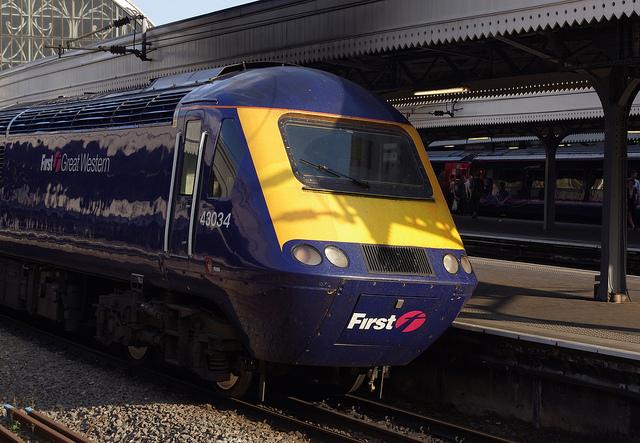Is the train located outdoors?
Write a very short answer. Yes. Why is everyone so far back in the train station?
Quick response, please. Safety. Are the headlights on?
Be succinct. No. What is the brand of train?
Short answer required. First. What number is on the left side of the train?
Write a very short answer. 43034. How many trains are there?
Be succinct. 1. What kind of train is this?
Answer briefly. Passenger. Does this train appear to be brand new?
Write a very short answer. Yes. 